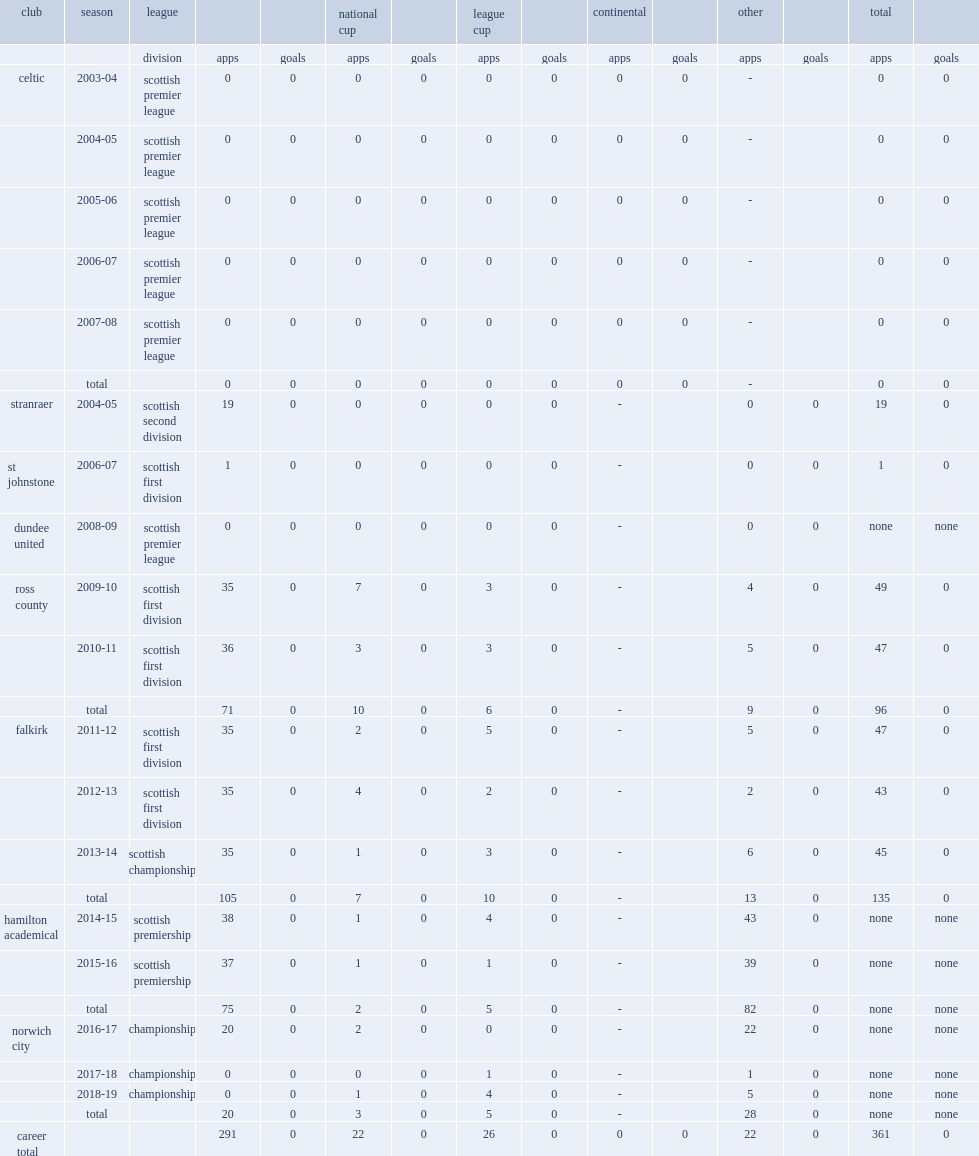Which club did mcgovern play for in 2010-11? Ross county. 